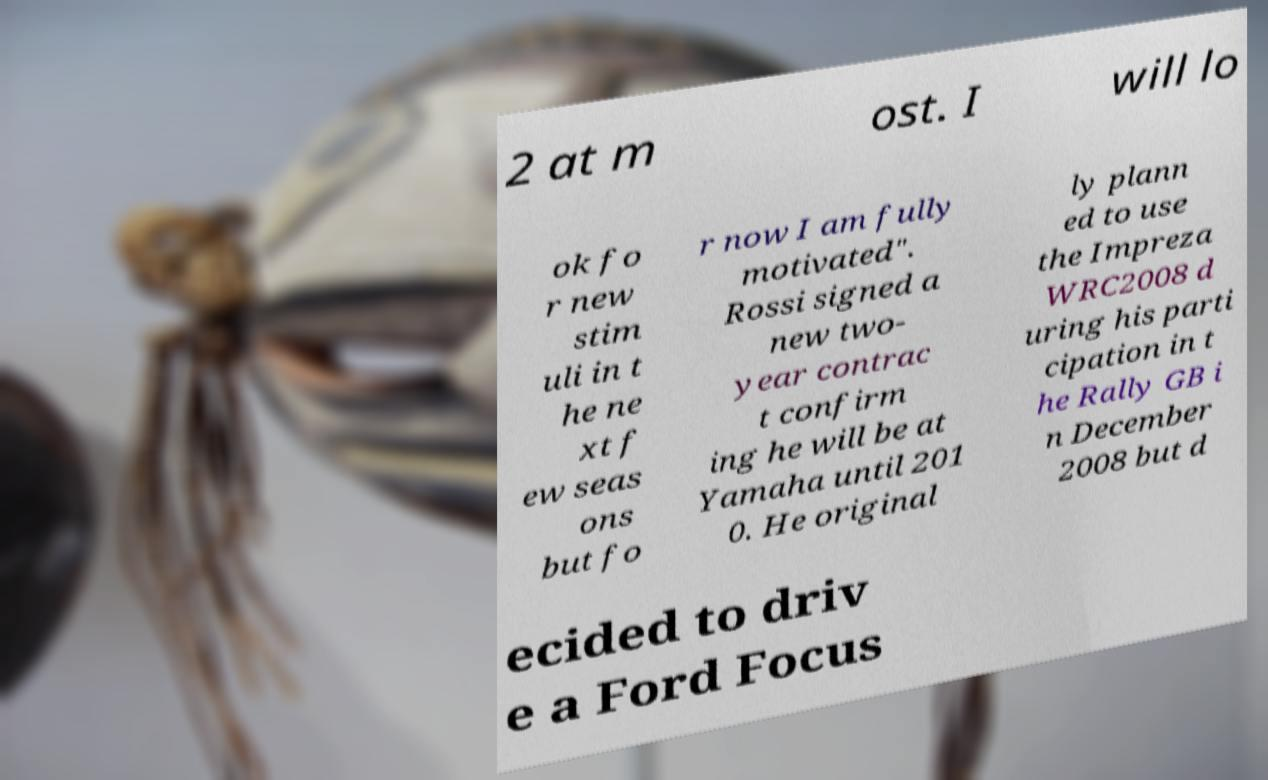Could you extract and type out the text from this image? 2 at m ost. I will lo ok fo r new stim uli in t he ne xt f ew seas ons but fo r now I am fully motivated". Rossi signed a new two- year contrac t confirm ing he will be at Yamaha until 201 0. He original ly plann ed to use the Impreza WRC2008 d uring his parti cipation in t he Rally GB i n December 2008 but d ecided to driv e a Ford Focus 